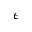Convert formula to latex. <formula><loc_0><loc_0><loc_500><loc_500>\epsilon</formula> 